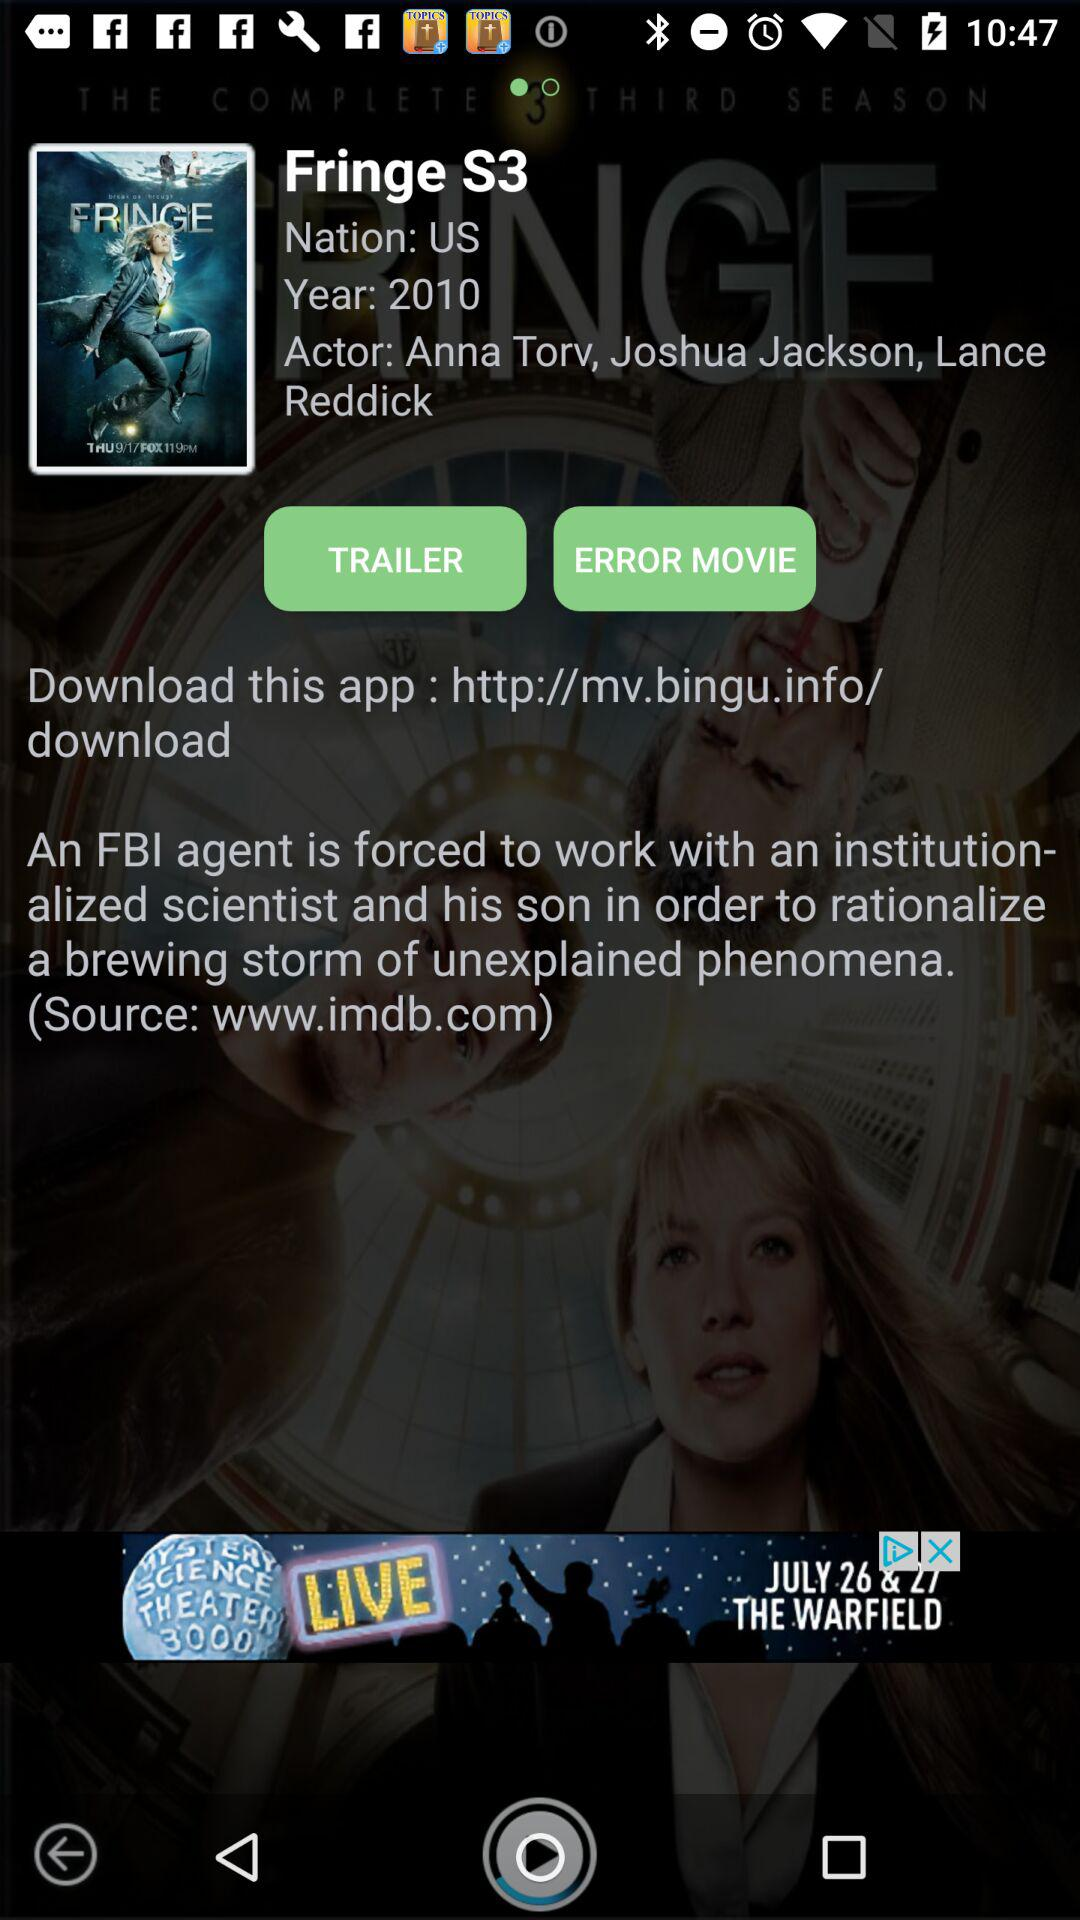What is the name of the nation? The name of the nation is the United States. 